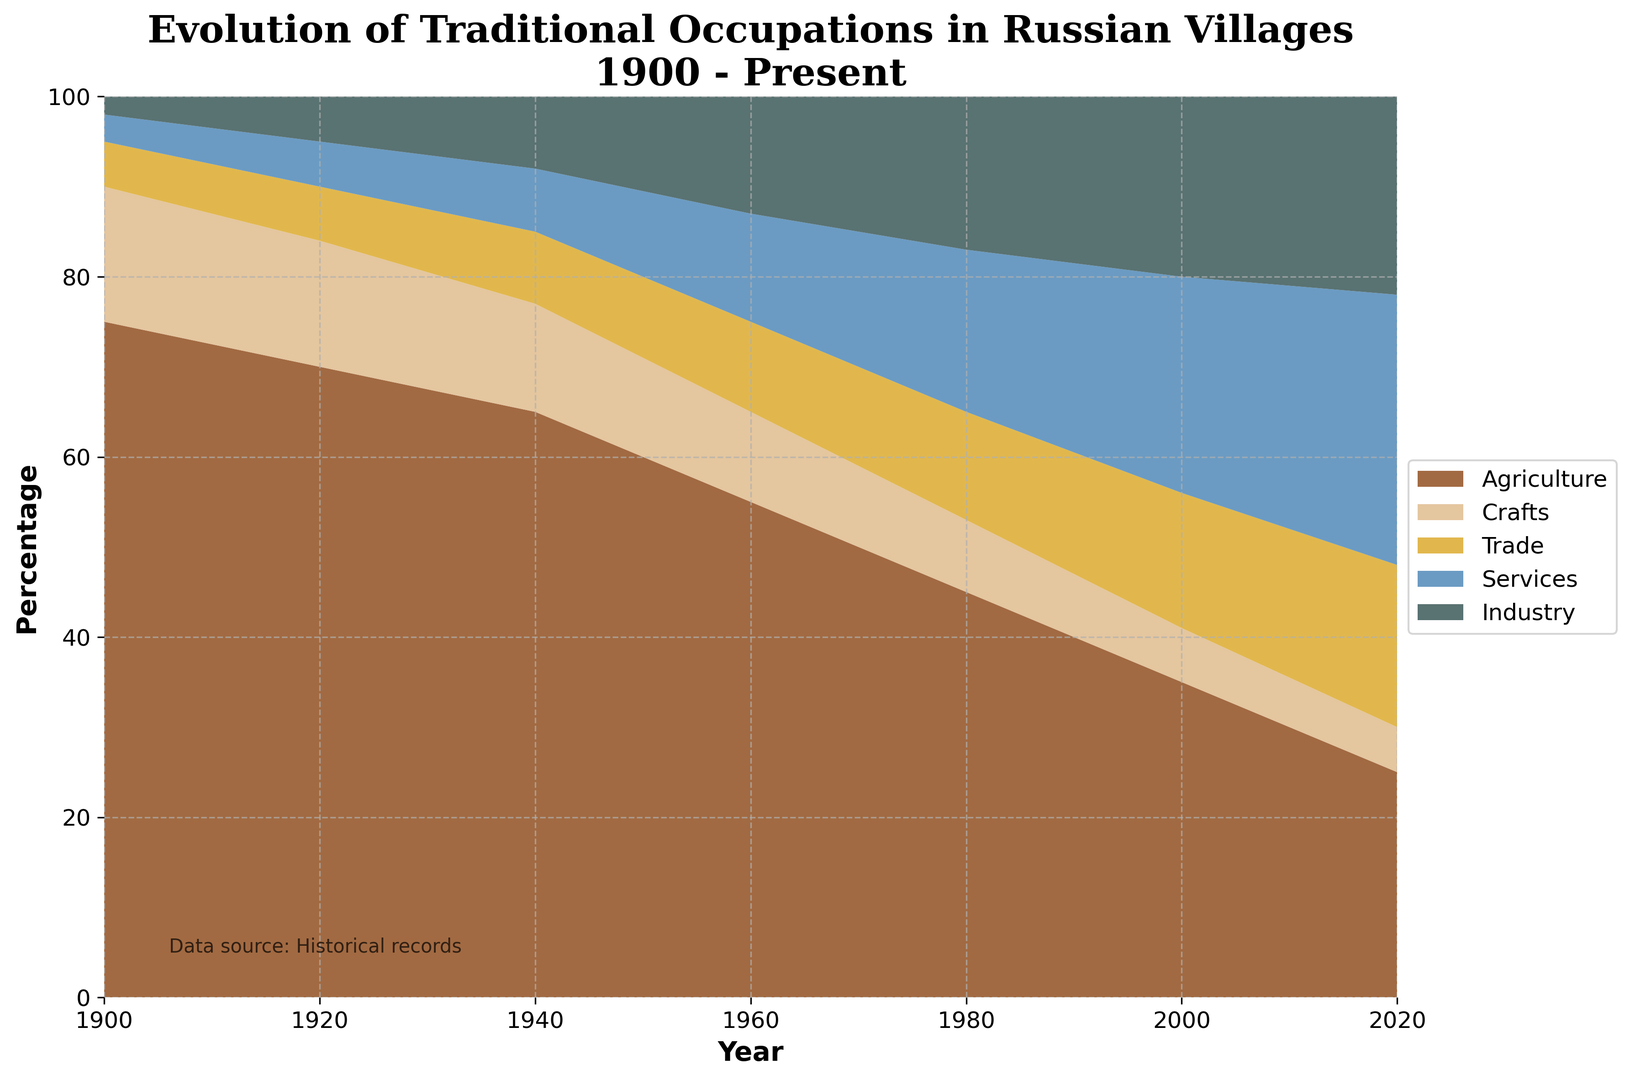how does the percentage of agriculture occupations change from 1900 to 2020? From the figure, the percentage of agriculture occupations goes from 75% in 1900 to 25% in 2020. This shows a decline in agriculture occupations over the years.
Answer: Declines from 75% to 25% compare the percentage of trades and services in 2020 In 2020, services occupy a larger area compared to trades. From the figure, the services percentage is 30%, while the trades percentage is 18%. Therefore, services are more prominent than trades in 2020.
Answer: Services are more than trades by 12% how does the area representing industry occupations change over the period? The visual representation shows that the area for industry occupations increases from a small percentage in 1900 to a larger percentage in 2020. Specifically, the percentage of industry occupations starts at 2% in 1900 and becomes 22% in 2020, illustrating significant growth.
Answer: Increases from 2% to 22% calculate the combined percentage of agriculture and services in 1980 In 1980, agriculture is at 45% and services are at 18%. Adding the two percentages together, the combined percentage is 45% + 18% = 63%.
Answer: 63% what is the trend for crafts from 1900 to 2020? The trend for crafts shows a decline over time. Starting from 15% in 1900, it gradually reduces every 20 years until it reaches 5% in 2020.
Answer: Declines from 15% to 5% which industry sector has grown the most from 1900 to 2020? To determine which sector has grown the most, observe the difference in percentages from 1900 to 2020 for each sector. Industry starts at 2% in 1900 and grows to 22% in 2020, a change of +20%. This is the largest increase compared to other sectors.
Answer: Industry (+20%) compare the percentages of agriculture and industry in 1960 In 1960, the visual shows that agriculture is significantly larger than industry. Agriculture is at 55%, while industry is at 13%. Thus, agriculture dominates over industry by 42%.
Answer: Agriculture is higher by 42% how much less is the percentage of crafts in 2000 compared to that in 1900? In 1900, the percentage of crafts is 15%, and in 2000, it is 6%. The difference is 15% - 6% = 9%. Crafts have declined by 9% from 1900 to 2000.
Answer: 9% which sector shows the most steady increase throughout the years? By observing the changes over the years, services show a steady and consistent increase from 3% in 1900 to 30% in 2020, indicating continuous growth.
Answer: Services 